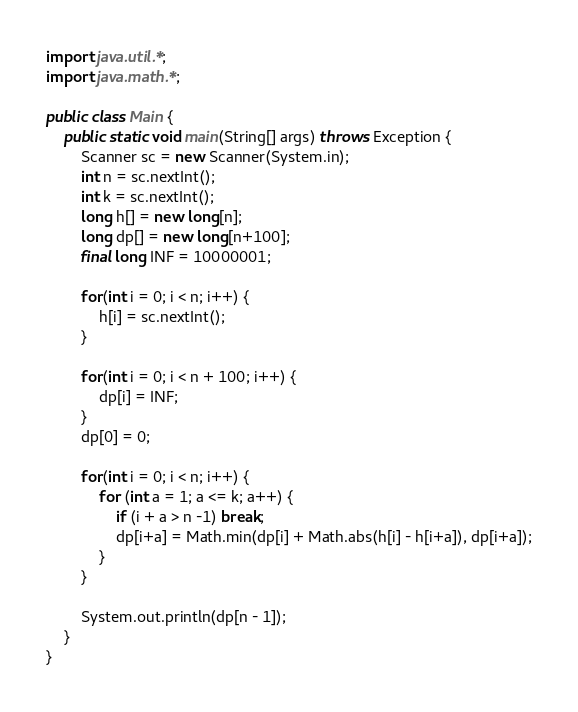Convert code to text. <code><loc_0><loc_0><loc_500><loc_500><_Java_>import java.util.*;
import java.math.*;

public class Main {
    public static void main(String[] args) throws Exception {
        Scanner sc = new Scanner(System.in);
        int n = sc.nextInt();
        int k = sc.nextInt();
        long h[] = new long[n];
        long dp[] = new long[n+100];
        final long INF = 10000001;
        
        for(int i = 0; i < n; i++) {
            h[i] = sc.nextInt();
        }
        
        for(int i = 0; i < n + 100; i++) {
            dp[i] = INF;
        }
        dp[0] = 0;
        
        for(int i = 0; i < n; i++) {
            for (int a = 1; a <= k; a++) {
                if (i + a > n -1) break;
                dp[i+a] = Math.min(dp[i] + Math.abs(h[i] - h[i+a]), dp[i+a]);
            }
        }
        
        System.out.println(dp[n - 1]);
    }
}
</code> 